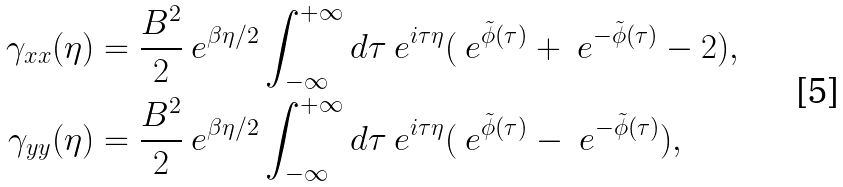Convert formula to latex. <formula><loc_0><loc_0><loc_500><loc_500>\gamma _ { x x } ( \eta ) & = \frac { B ^ { 2 } } { 2 } \ e ^ { \beta \eta / 2 } \int _ { - \infty } ^ { + \infty } d \tau \ e ^ { i \tau \eta } ( \ e ^ { \tilde { \phi } ( \tau ) } + \ e ^ { - \tilde { \phi } ( \tau ) } - 2 ) , \\ \gamma _ { y y } ( \eta ) & = \frac { B ^ { 2 } } { 2 } \ e ^ { \beta \eta / 2 } \int _ { - \infty } ^ { + \infty } d \tau \ e ^ { i \tau \eta } ( \ e ^ { \tilde { \phi } ( \tau ) } - \ e ^ { - \tilde { \phi } ( \tau ) } ) ,</formula> 